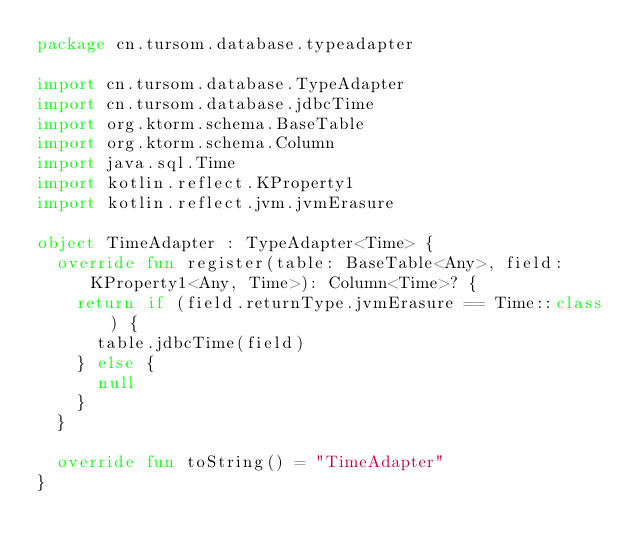<code> <loc_0><loc_0><loc_500><loc_500><_Kotlin_>package cn.tursom.database.typeadapter

import cn.tursom.database.TypeAdapter
import cn.tursom.database.jdbcTime
import org.ktorm.schema.BaseTable
import org.ktorm.schema.Column
import java.sql.Time
import kotlin.reflect.KProperty1
import kotlin.reflect.jvm.jvmErasure

object TimeAdapter : TypeAdapter<Time> {
  override fun register(table: BaseTable<Any>, field: KProperty1<Any, Time>): Column<Time>? {
    return if (field.returnType.jvmErasure == Time::class) {
      table.jdbcTime(field)
    } else {
      null
    }
  }

  override fun toString() = "TimeAdapter"
}</code> 